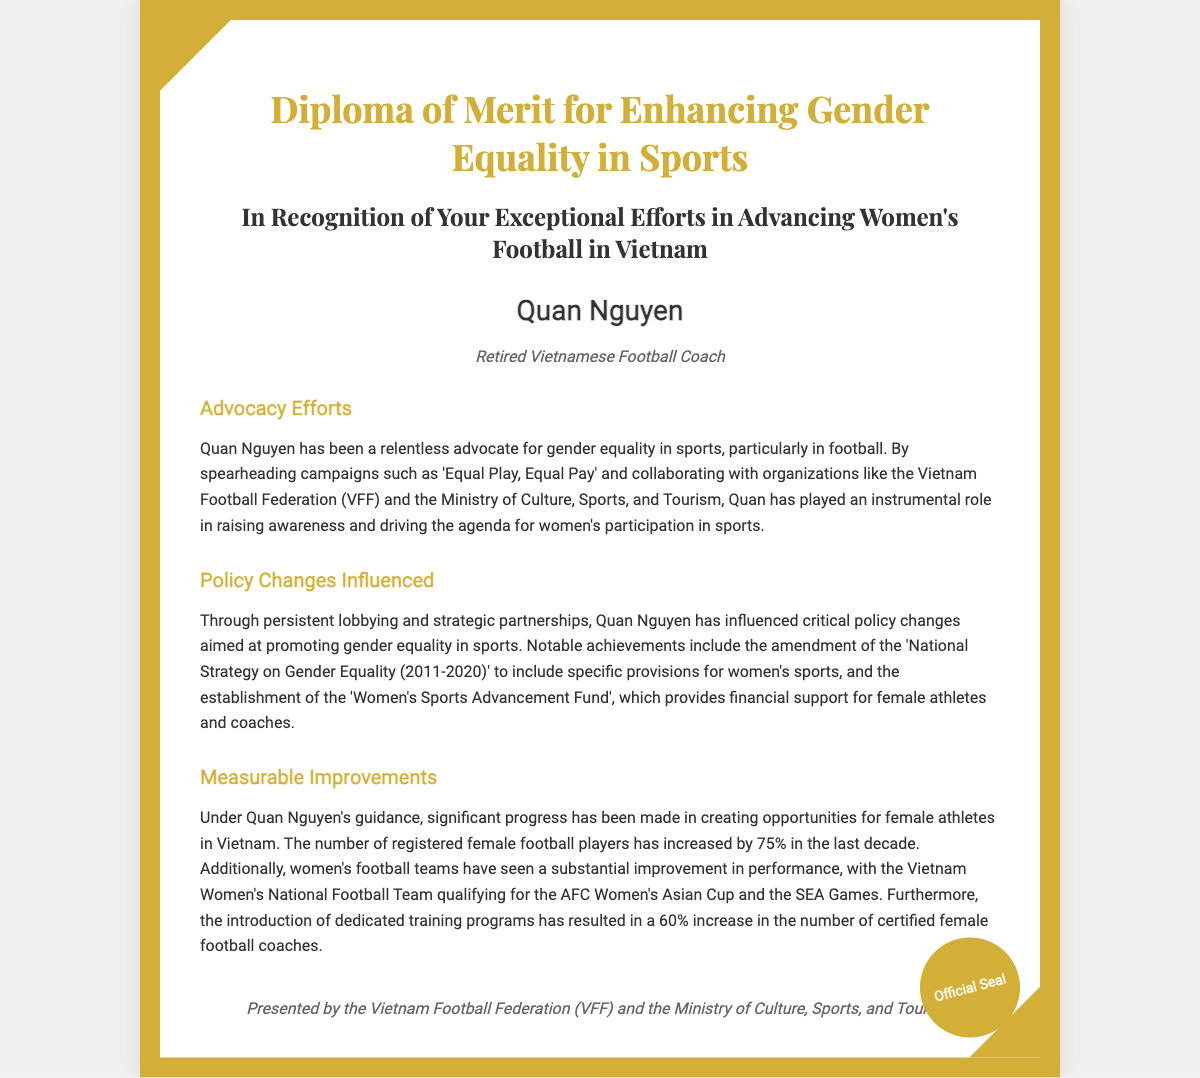What is the title of the diploma? The title of the diploma is explicitly mentioned at the top of the document.
Answer: Diploma of Merit for Enhancing Gender Equality in Sports Who is the recipient of the diploma? The recipient's name is stated prominently in the document.
Answer: Quan Nguyen What is the role of Quan Nguyen? Quan Nguyen's role is specified below their name in the diploma.
Answer: Retired Vietnamese Football Coach What campaign did Quan Nguyen spearhead? The document mentions specific campaigns associated with Quan Nguyen's advocacy.
Answer: Equal Play, Equal Pay What organization collaborated with Quan Nguyen? The document specifies organizations that collaborated with Quan Nguyen in advocacy efforts.
Answer: Vietnam Football Federation (VFF) By what percentage did the number of registered female football players increase? The document includes a specific measurement about the increase in female football players.
Answer: 75% What fund was established to support female athletes? The document mentions a specific fund created for supporting female athletes.
Answer: Women's Sports Advancement Fund What notable achievement did the Vietnam Women's National Football Team accomplish? The document highlights a significant accomplishment by the team.
Answer: Qualifying for the AFC Women's Asian Cup How much did the number of certified female football coaches increase? The document provides a measurable improvement regarding female football coaches.
Answer: 60% 